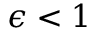<formula> <loc_0><loc_0><loc_500><loc_500>\epsilon < 1</formula> 